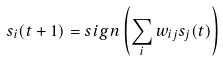<formula> <loc_0><loc_0><loc_500><loc_500>s _ { i } ( t + 1 ) = s i g n \left ( \sum _ { i } w _ { i j } s _ { j } ( t ) \right )</formula> 